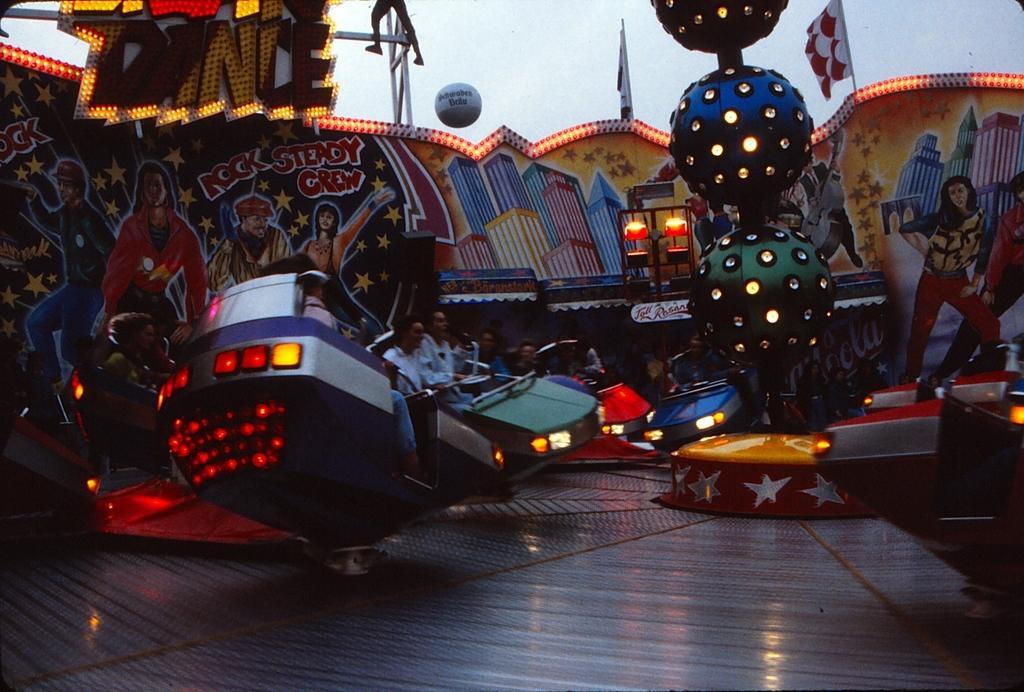Describe this image in one or two sentences. In this picture we can see a few people on rides. There are some posters from left to right. We can see some lights. 